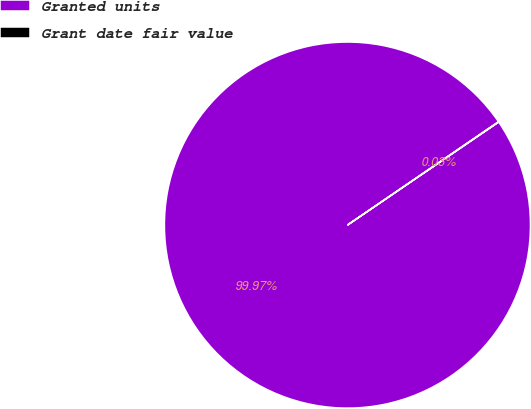Convert chart. <chart><loc_0><loc_0><loc_500><loc_500><pie_chart><fcel>Granted units<fcel>Grant date fair value<nl><fcel>99.97%<fcel>0.03%<nl></chart> 